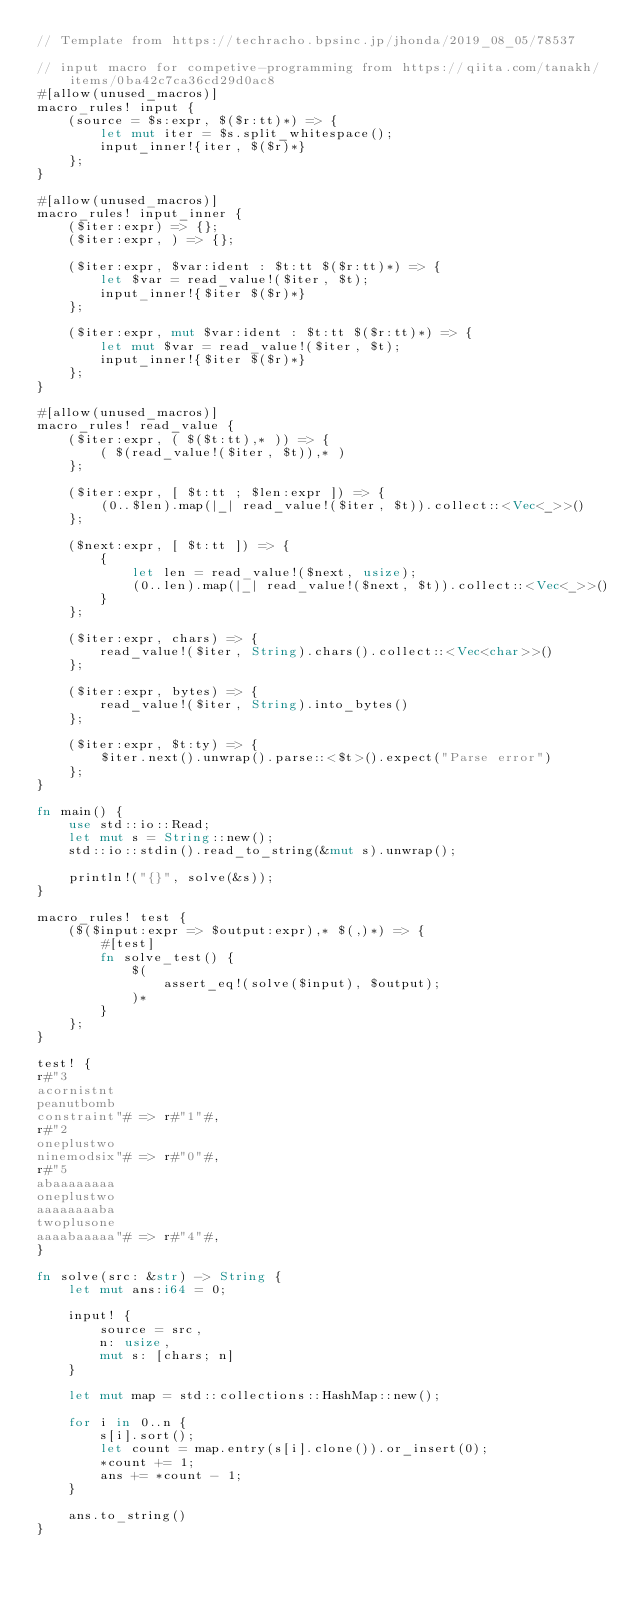<code> <loc_0><loc_0><loc_500><loc_500><_Rust_>// Template from https://techracho.bpsinc.jp/jhonda/2019_08_05/78537

// input macro for competive-programming from https://qiita.com/tanakh/items/0ba42c7ca36cd29d0ac8
#[allow(unused_macros)]
macro_rules! input {
    (source = $s:expr, $($r:tt)*) => {
        let mut iter = $s.split_whitespace();
        input_inner!{iter, $($r)*}
    };
}

#[allow(unused_macros)]
macro_rules! input_inner {
    ($iter:expr) => {};
    ($iter:expr, ) => {};

    ($iter:expr, $var:ident : $t:tt $($r:tt)*) => {
        let $var = read_value!($iter, $t);
        input_inner!{$iter $($r)*}
    };

    ($iter:expr, mut $var:ident : $t:tt $($r:tt)*) => {
        let mut $var = read_value!($iter, $t);
        input_inner!{$iter $($r)*}
    };
}

#[allow(unused_macros)]
macro_rules! read_value {
    ($iter:expr, ( $($t:tt),* )) => {
        ( $(read_value!($iter, $t)),* )
    };

    ($iter:expr, [ $t:tt ; $len:expr ]) => {
        (0..$len).map(|_| read_value!($iter, $t)).collect::<Vec<_>>()
    };

    ($next:expr, [ $t:tt ]) => {
        {
            let len = read_value!($next, usize);
            (0..len).map(|_| read_value!($next, $t)).collect::<Vec<_>>()
        }
    };

    ($iter:expr, chars) => {
        read_value!($iter, String).chars().collect::<Vec<char>>()
    };

    ($iter:expr, bytes) => {
        read_value!($iter, String).into_bytes()
    };

    ($iter:expr, $t:ty) => {
        $iter.next().unwrap().parse::<$t>().expect("Parse error")
    };
}

fn main() {
    use std::io::Read;
    let mut s = String::new();
    std::io::stdin().read_to_string(&mut s).unwrap();

    println!("{}", solve(&s));
}

macro_rules! test {
    ($($input:expr => $output:expr),* $(,)*) => {
        #[test]
        fn solve_test() {
            $(
                assert_eq!(solve($input), $output);
            )*
        }
    };
}

test! {
r#"3
acornistnt
peanutbomb
constraint"# => r#"1"#,
r#"2
oneplustwo
ninemodsix"# => r#"0"#,
r#"5
abaaaaaaaa
oneplustwo
aaaaaaaaba
twoplusone
aaaabaaaaa"# => r#"4"#,
}

fn solve(src: &str) -> String {
    let mut ans:i64 = 0;

    input! {
        source = src,
        n: usize,
        mut s: [chars; n]
    }

    let mut map = std::collections::HashMap::new();

    for i in 0..n {
        s[i].sort();
        let count = map.entry(s[i].clone()).or_insert(0);
        *count += 1;
        ans += *count - 1;
    }

    ans.to_string()
}</code> 